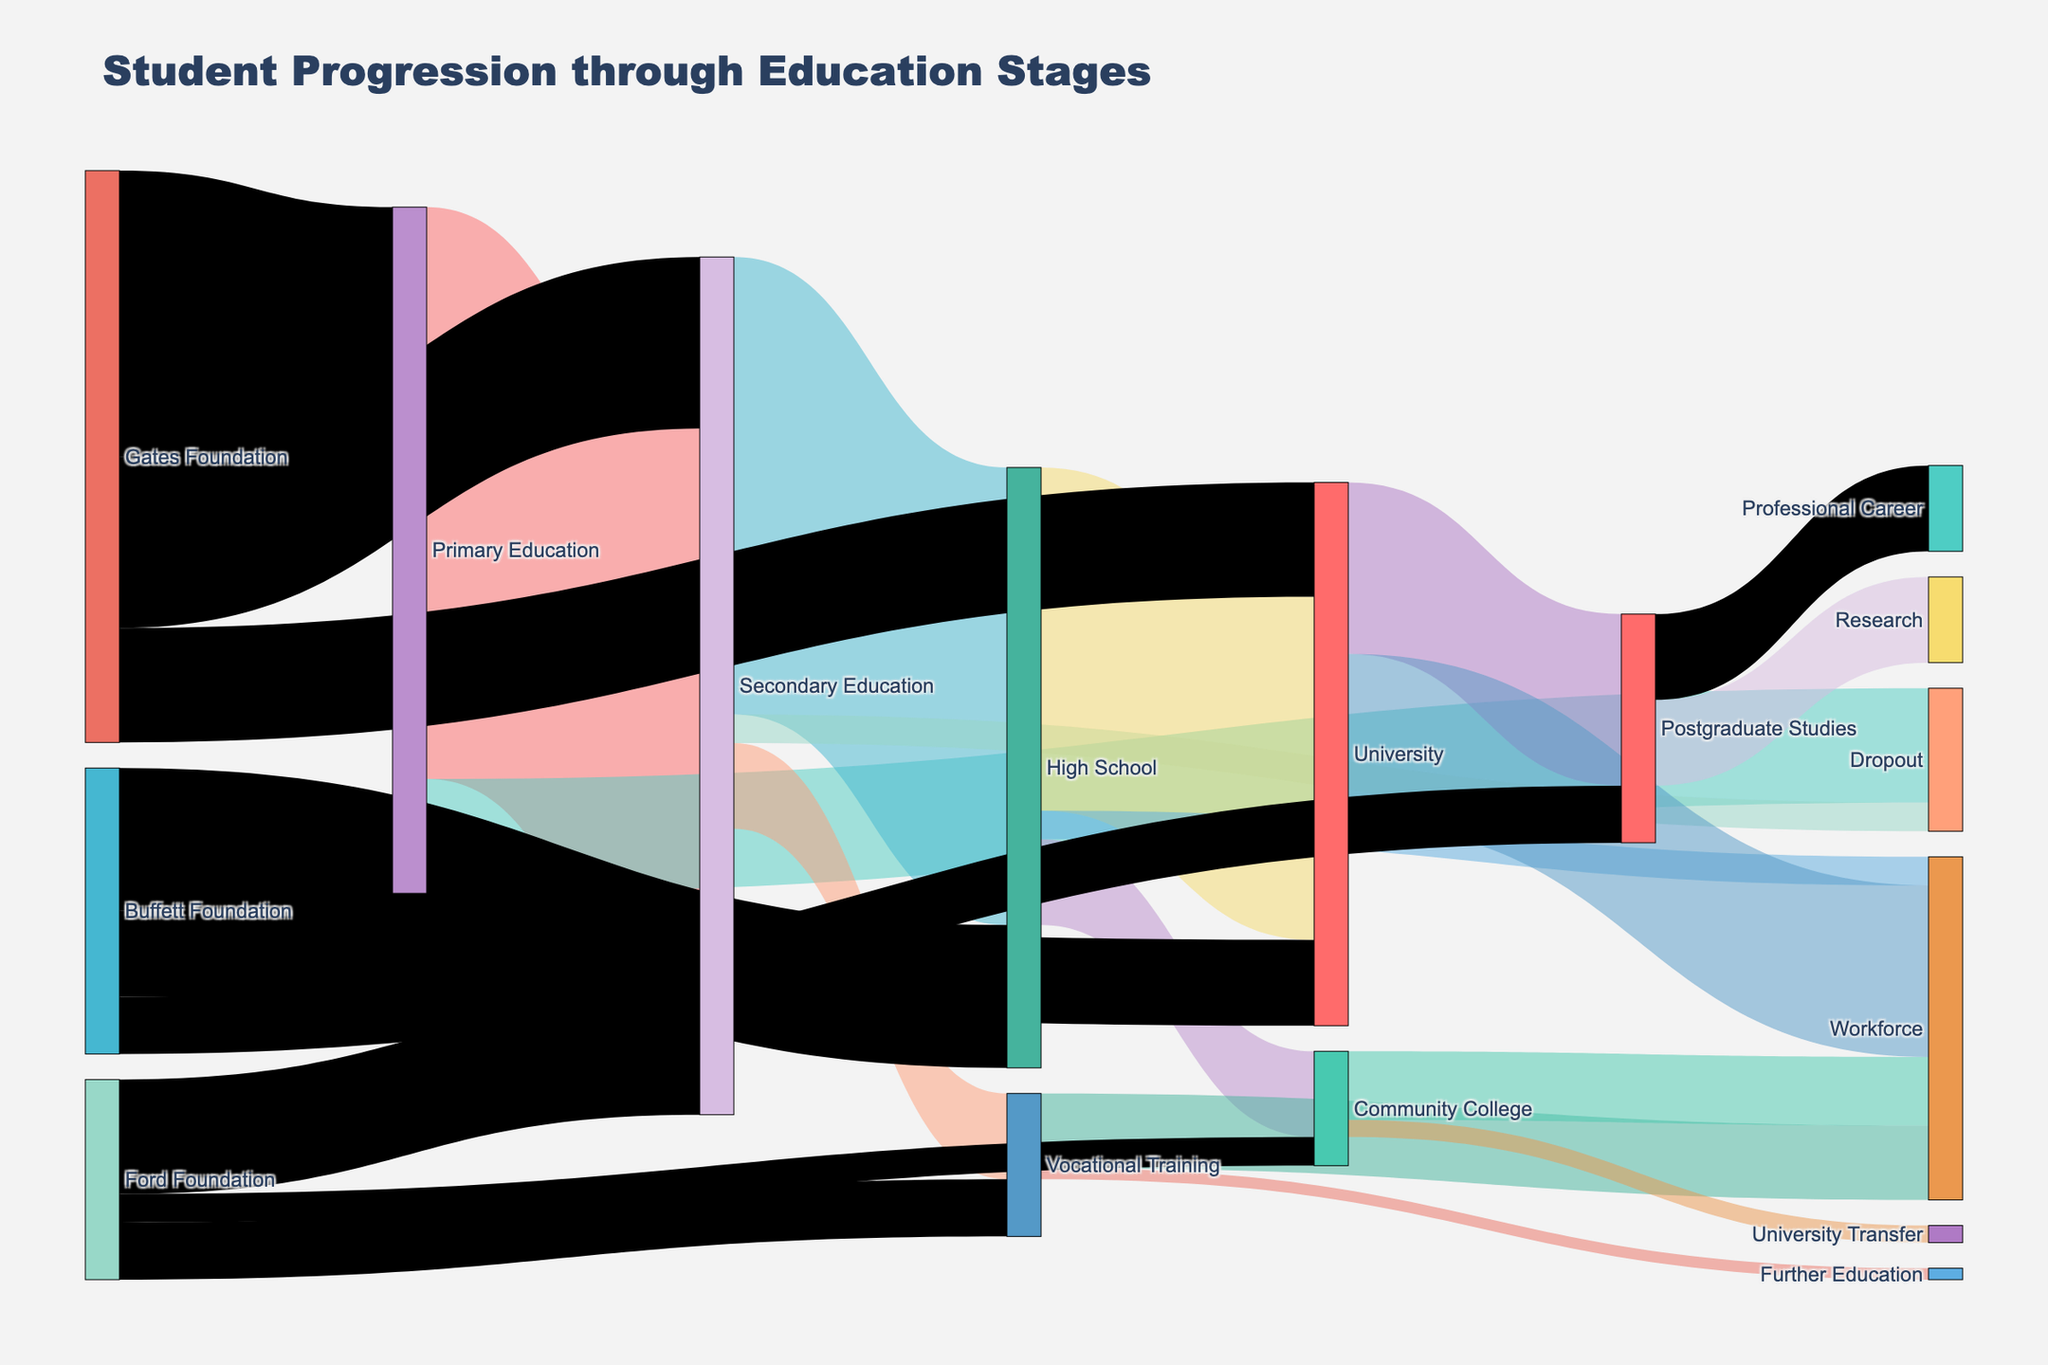What is the total number of students who completed Primary Education? To find the total number of students who completed Primary Education, sum the values of all the flows originating from 'Primary Education'. These are 'Primary Education' to 'Secondary Education' (1000) and 'Primary Education' to 'Dropout' (200). The total is 1000 + 200 = 1200.
Answer: 1200 How many students transitioned from Secondary Education to High School? Look at the value associated with the flow from 'Secondary Education' to 'High School' in the diagram. This value is 800.
Answer: 800 What percentage of Secondary Education students dropped out? First, find the total number of students in Secondary Education. It consists of students from 'Primary Education' (1000) and the donations, Gates Foundation (300) and Ford Foundation (200), totaling 1000 + 300 + 200 = 1500. Now, find the number of students who dropped out from Secondary Education, which is 50. The percentage is (50 / 1500) * 100 = approximately 3.33%.
Answer: 3.33% Which stage did most students enter the Workforce directly from? Compare the values of each flow leading to the 'Workforce'. These are 'High School' to 'Workforce' (50), 'Vocational Training' to 'Workforce' (130), 'University' to 'Workforce' (300), and 'Community College' to 'Workforce' (120). The largest flow is from 'University' with 300 students.
Answer: University What is the total number of students supported by the Gates Foundation at all stages? Sum the values of all the flows originating from 'Gates Foundation': 'Primary Education' (500), 'Secondary Education' (300), and 'University' (200). The total is 500 + 300 + 200 = 1000.
Answer: 1000 How many students proceeded from Vocational Training to Further Education? Look at the value associated with the flow from 'Vocational Training' to 'Further Education' in the diagram. This value is 20.
Answer: 20 Which foundation contributed the most to Postgraduate Studies? Compare the values of the flows leading from each foundation to 'Postgraduate Studies'. Gates Foundation does not contribute directly to 'Postgraduate Studies'. Ford Foundation and Buffett Foundation also have no direct contributions to 'Postgraduate Studies'. Hence, the answer is none.
Answer: None What percentage of University students went on to Postgraduate Studies? From the diagram, the flow from 'High School' to 'University' is 600. The number of students entering University via direct donations from foundations is 200, making a total of 600 + 200 = 800. The number of students progressing to 'Postgraduate Studies' from 'University' is 300. The percentage is (300 / 800) * 100 = 37.5%.
Answer: 37.5% What stage has the highest total inflow of students? Sum the inflows for each stage: 'Primary Education' (500 from Gates Foundation), 'Secondary Education' (1000 from Primary and 300 from Gates and 200 from Ford, totaling 1500), 'High School' (800 from Secondary and 250 from Buffett, totaling 1050), and so on. The stage with the highest total inflow is 'Secondary Education' with 1500 students.
Answer: Secondary Education How many students successfully transitioned from Community College to a University Transfer? Look at the value associated with the flow from 'Community College' to 'University Transfer' in the diagram. This value is 30.
Answer: 30 